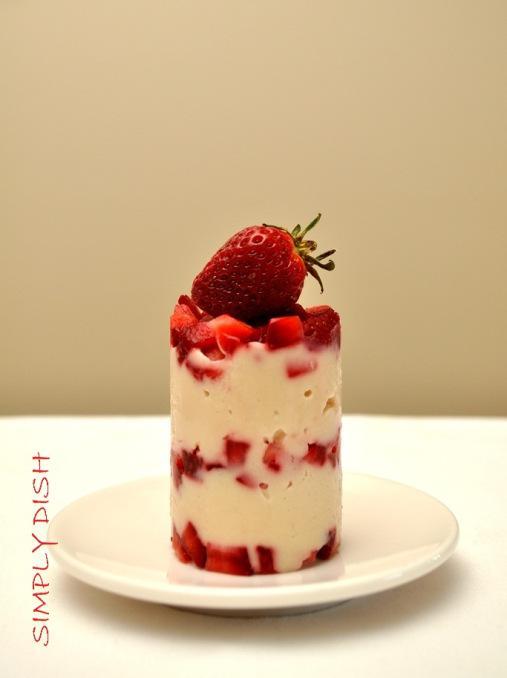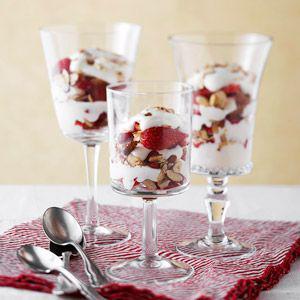The first image is the image on the left, the second image is the image on the right. Evaluate the accuracy of this statement regarding the images: "There is one large trifle bowl that has fresh strawberries and blueberries on top.". Is it true? Answer yes or no. No. 